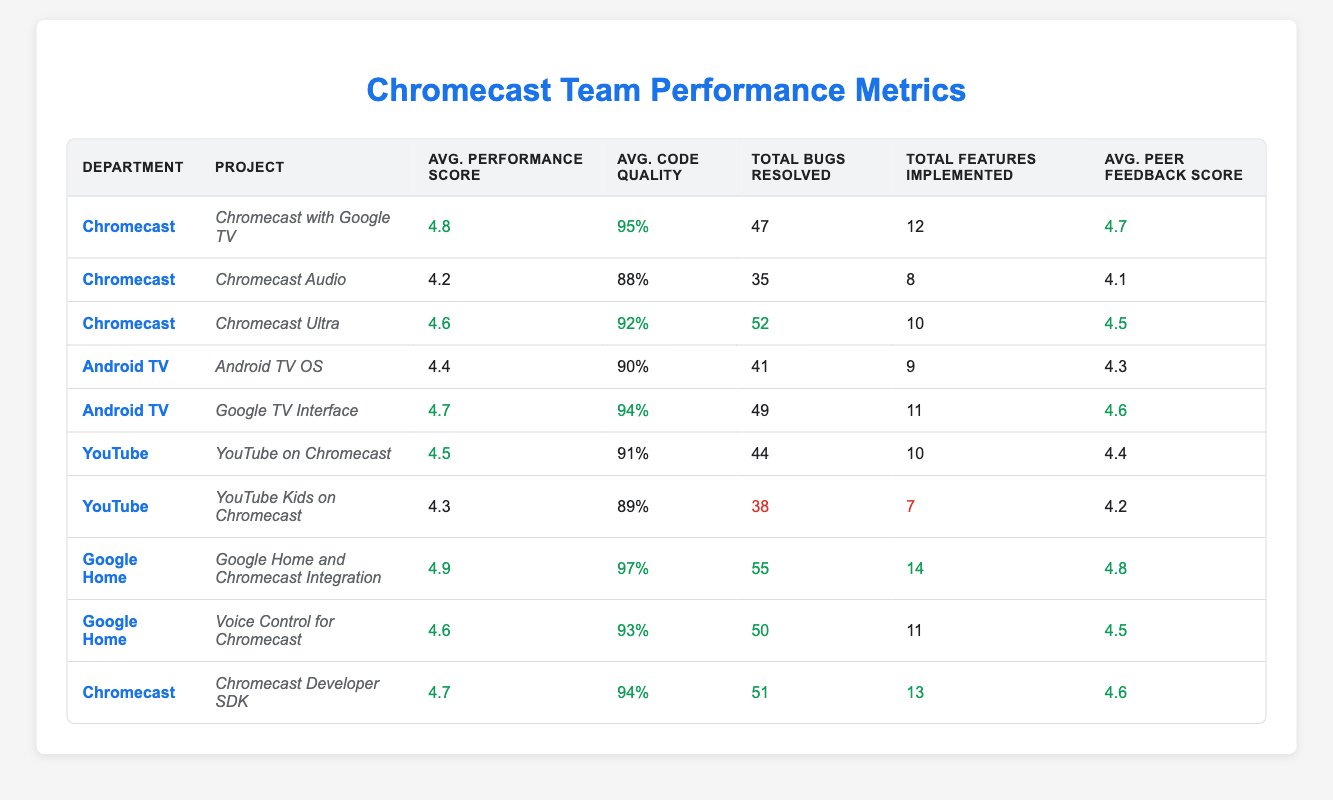What is the performance score of Alice Chen? Alice Chen is listed under the Chromecast department, and her performance score is explicitly stated in the table as 4.8.
Answer: 4.8 Which project under the Chromecast department has the highest average performance score? The table lists three projects under the Chromecast department: Chromecast with Google TV (4.8), Chromecast Audio (4.2), and Chromecast Ultra (4.6). The highest score is for Chromecast with Google TV at 4.8.
Answer: Chromecast with Google TV What is the average code quality of the Android TV department? Adding the code quality scores of both projects (Android TV OS: 90% and Google TV Interface: 94%) gives 184%. Dividing by 2 (since there are 2 projects) yields an average code quality of 92%.
Answer: 92% Is the total number of bugs resolved by the Google Home department greater than the total number of features implemented by the Chromecast department? The Google Home department resolved a total of 105 bugs (55 + 50), while the Chromecast department implemented a total of 43 features (12 + 8 + 10 + 13). Since 105 > 43, the statement is true.
Answer: Yes Which project has the lowest peer feedback score, and what is that score? From the table, looking at the peer feedback scores, YouTube Kids on Chromecast has the lowest score at 4.2, while the other projects have higher scores.
Answer: 4.2 